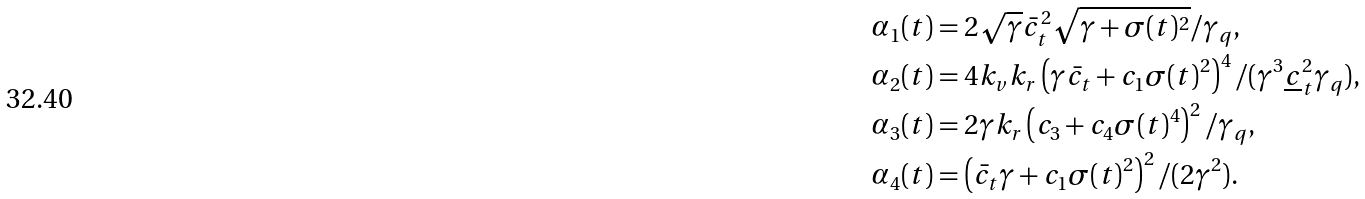Convert formula to latex. <formula><loc_0><loc_0><loc_500><loc_500>\alpha _ { 1 } ( t ) & = 2 \sqrt { \gamma } \bar { c } _ { t } ^ { 2 } \sqrt { \gamma + \sigma ( t ) ^ { 2 } } / \gamma _ { q } , \\ \alpha _ { 2 } ( t ) & = 4 k _ { v } k _ { r } \left ( \gamma \bar { c } _ { t } + c _ { 1 } \sigma ( t ) ^ { 2 } \right ) ^ { 4 } / ( \gamma ^ { 3 } \underline { c } _ { t } ^ { 2 } \gamma _ { q } ) , \\ \alpha _ { 3 } ( t ) & = 2 \gamma k _ { r } \left ( c _ { 3 } + c _ { 4 } \sigma ( t ) ^ { 4 } \right ) ^ { 2 } / \gamma _ { q } , \\ \alpha _ { 4 } ( t ) & = \left ( \bar { c } _ { t } \gamma + c _ { 1 } \sigma ( t ) ^ { 2 } \right ) ^ { 2 } / ( 2 \gamma ^ { 2 } ) .</formula> 